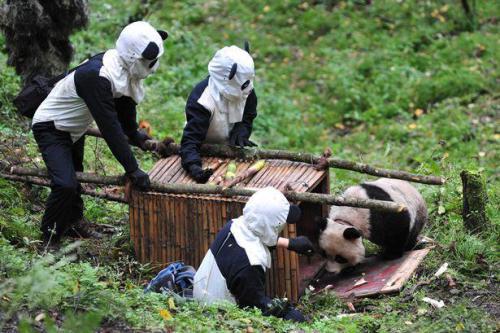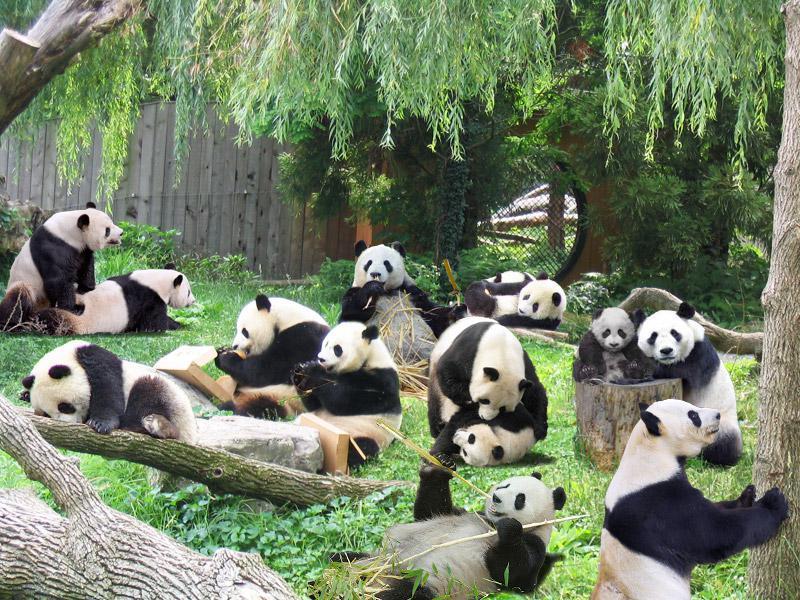The first image is the image on the left, the second image is the image on the right. For the images shown, is this caption "There is a single panda in one of the images." true? Answer yes or no. Yes. The first image is the image on the left, the second image is the image on the right. Examine the images to the left and right. Is the description "There are at most three pandas in one of the images." accurate? Answer yes or no. No. 